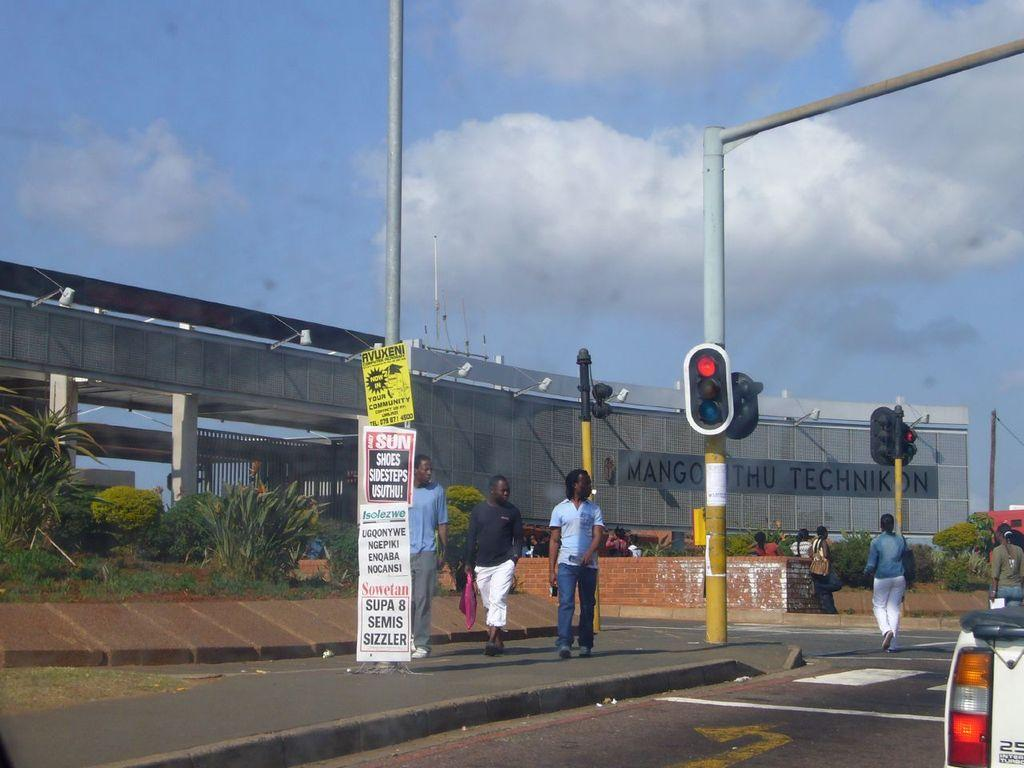<image>
Provide a brief description of the given image. A pole with posters on it, one reads Supa 8 semis sizzler on it. 